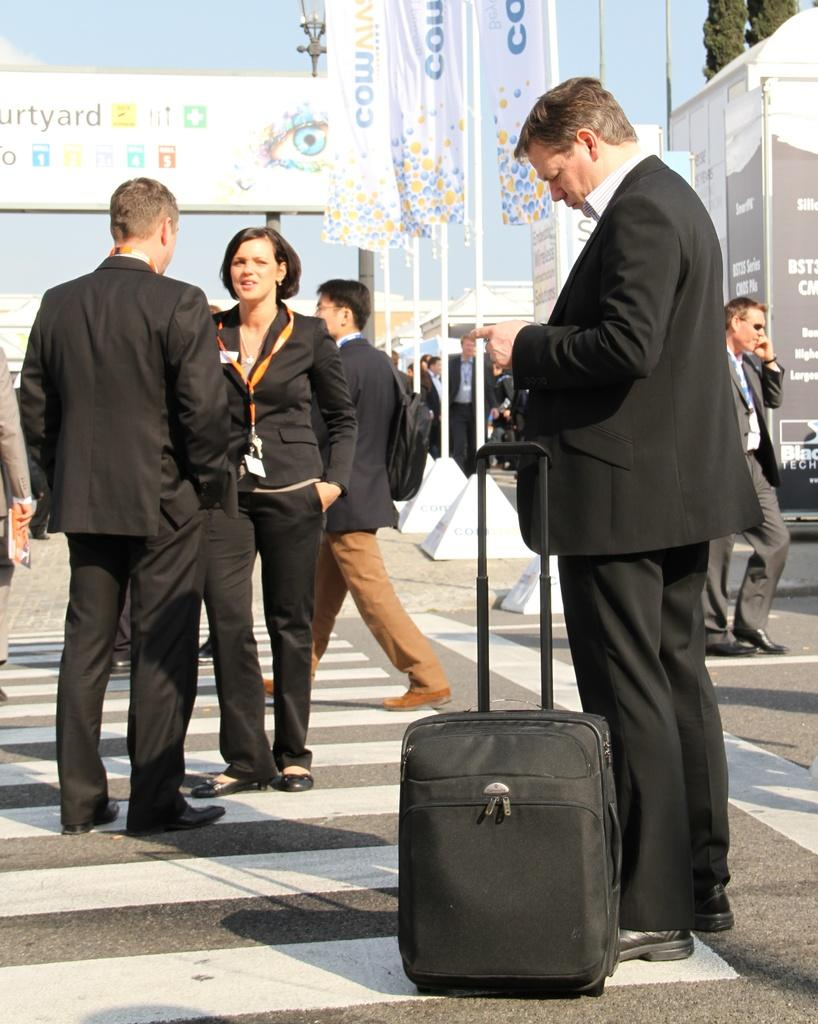What can be seen in the background of the image? The sky is visible in the image. What type of object is present in the image that provides light? There is a street lamp in the image. What is hanging or displayed in the image? There is a banner in the image. Are there any people in the image? Yes, there are people present in the image. Can you describe the man on the right side of the image? The man is standing on the right side of the image, and he is holding a suitcase. What color are the mom's eyes in the image? There is no mom present in the image, so it is not possible to answer that question. 